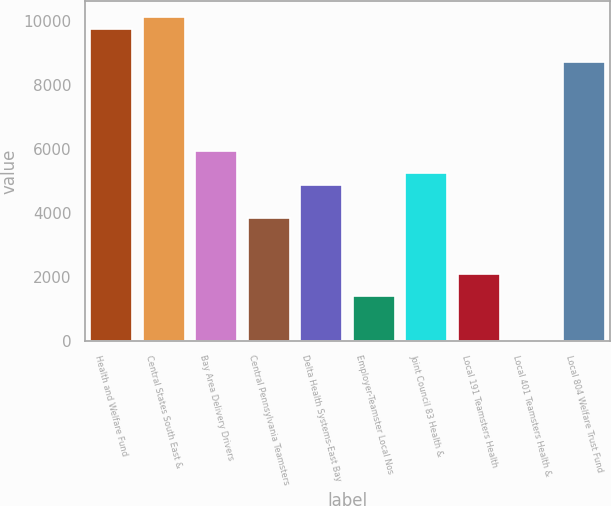Convert chart to OTSL. <chart><loc_0><loc_0><loc_500><loc_500><bar_chart><fcel>Health and Welfare Fund<fcel>Central States South East &<fcel>Bay Area Delivery Drivers<fcel>Central Pennsylvania Teamsters<fcel>Delta Health Systems-East Bay<fcel>Employer-Teamster Local Nos<fcel>Joint Council 83 Health &<fcel>Local 191 Teamsters Health<fcel>Local 401 Teamsters Health &<fcel>Local 804 Welfare Trust Fund<nl><fcel>9748.2<fcel>10096.1<fcel>5921.3<fcel>3833.9<fcel>4877.6<fcel>1398.6<fcel>5225.5<fcel>2094.4<fcel>7<fcel>8704.5<nl></chart> 